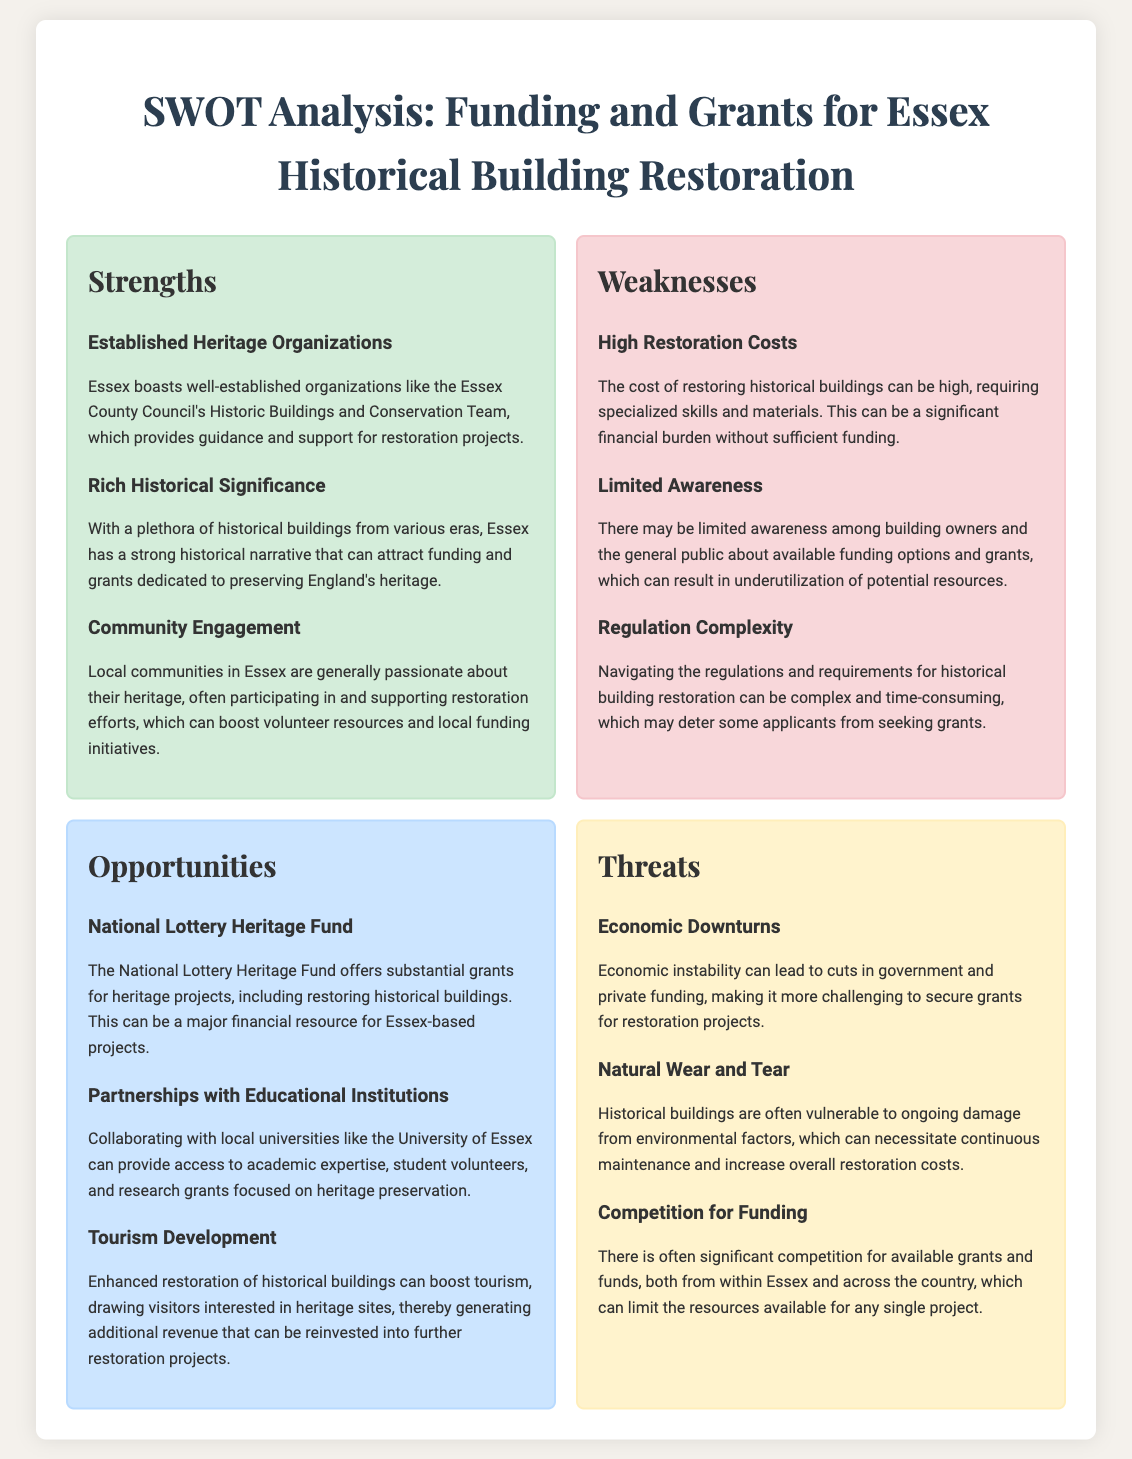What are the strengths mentioned for Essex historical restoration? The strengths listed are the established heritage organizations, rich historical significance, and community engagement in Essex.
Answer: Established Heritage Organizations, Rich Historical Significance, Community Engagement What is the primary funding source highlighted in the opportunities section? The opportunities section mentions the National Lottery Heritage Fund as a major financial resource for restoration projects.
Answer: National Lottery Heritage Fund What weakness is associated with high costs in restoration? The document states that the high restoration costs can be a significant financial burden without sufficient funding.
Answer: High Restoration Costs Which local university is suggested for partnerships in restoration projects? The document mentions collaborating with the University of Essex for academic expertise and research grants.
Answer: University of Essex What threat is related to competition for funding? There is a significant competition for available grants and funds, which limits resources for projects.
Answer: Competition for Funding How many strengths are identified in the SWOT analysis? There are three strengths identified in the strengths section of the SWOT analysis.
Answer: Three What section includes information about natural wear and tear? The threats section discusses natural wear and tear as a vulnerability of historical buildings.
Answer: Threats What is the focus of community engagement according to the strengths section? The community engagement in Essex focuses on participating in and supporting restoration efforts.
Answer: Supporting restoration efforts What economic issue is listed as a threat to funding? The document identifies economic downturns as a threat that can lead to cuts in funding.
Answer: Economic Downturns 